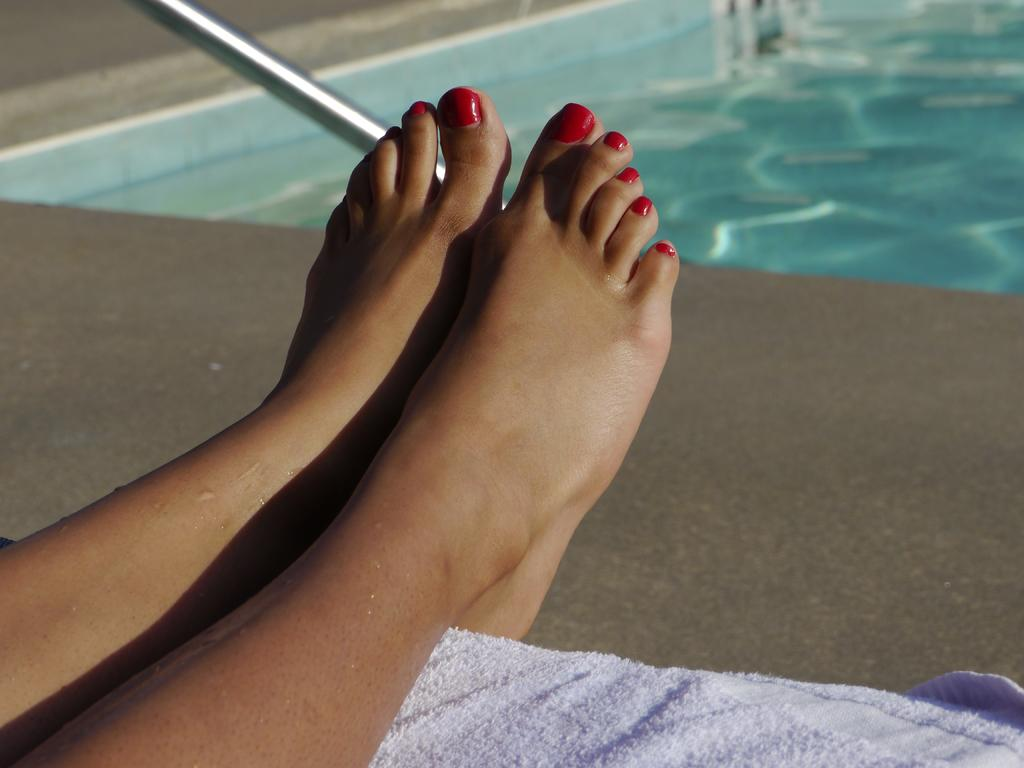What body parts of a person can be seen in the image? A person's legs are visible in the image. What is the legs placed on? The legs are placed on a cloth. What type of surface is visible beneath the cloth? There is a floor visible in the image. What can be seen on the right side of the image? There is a pole with water on the right side of the image. What is located on the left top of the image? There is a metal rod on the left top of the image. How many girls are playing with the pet in the yard in the image? There is no mention of girls, a pet, or a yard in the image. The image only describes a person's legs, a cloth, a floor, a pole with water, and a metal rod. 